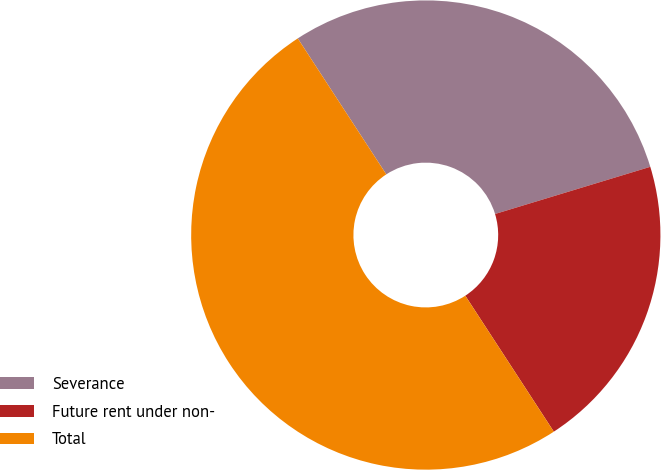Convert chart. <chart><loc_0><loc_0><loc_500><loc_500><pie_chart><fcel>Severance<fcel>Future rent under non-<fcel>Total<nl><fcel>29.49%<fcel>20.51%<fcel>50.0%<nl></chart> 